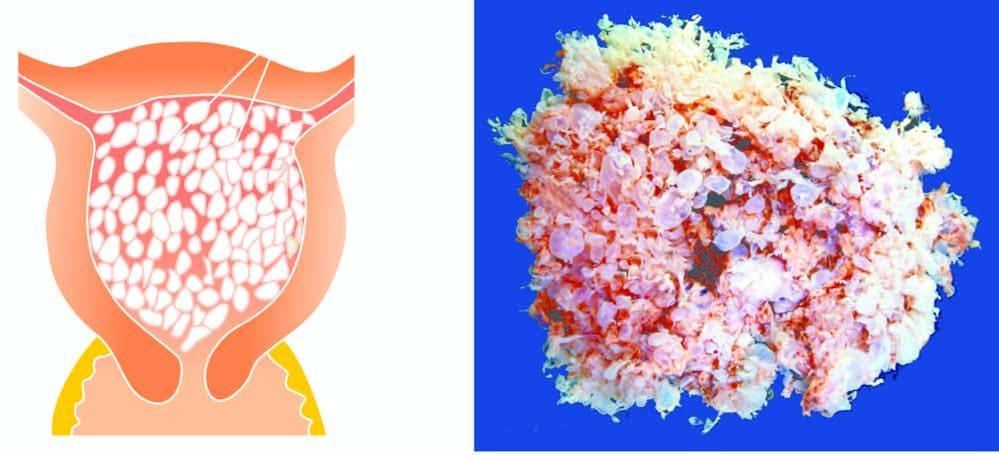does the specimen show numerous, variable-sized, grape-like translucent vesicles containing clear fluid?
Answer the question using a single word or phrase. Yes 